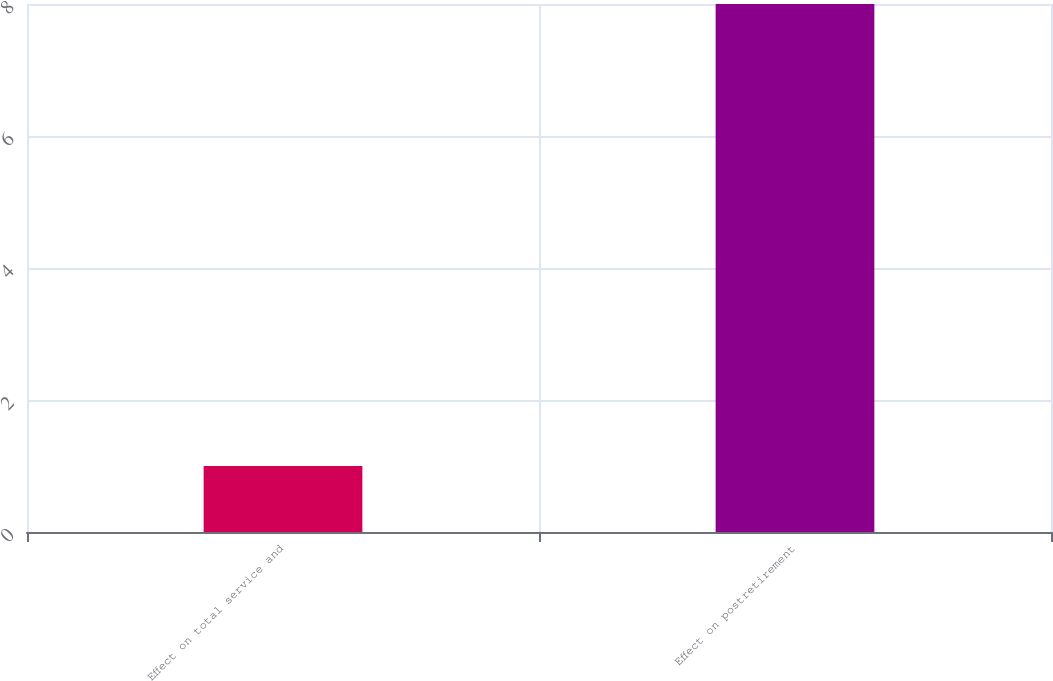<chart> <loc_0><loc_0><loc_500><loc_500><bar_chart><fcel>Effect on total service and<fcel>Effect on postretirement<nl><fcel>1<fcel>8<nl></chart> 